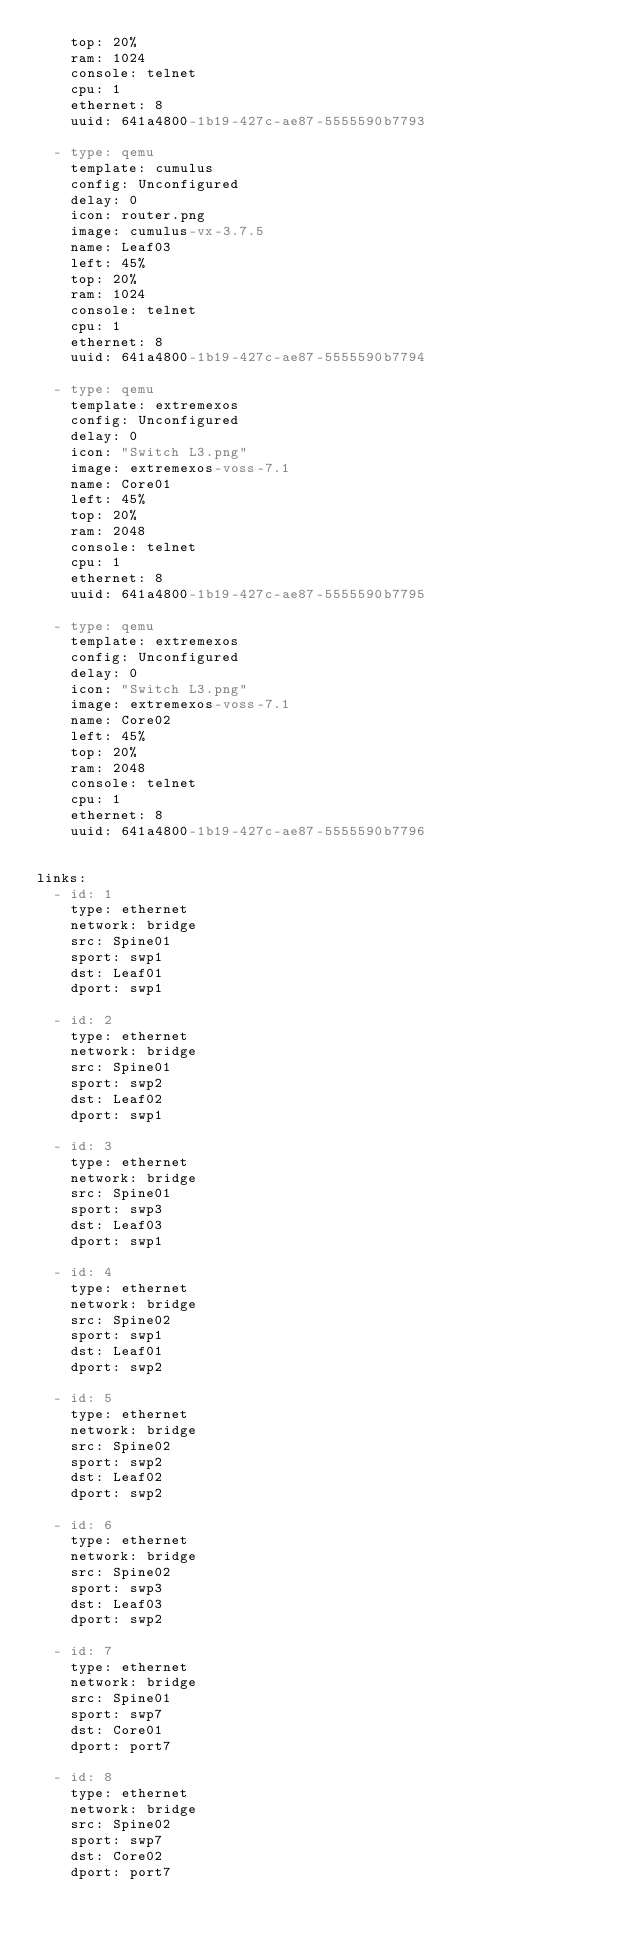Convert code to text. <code><loc_0><loc_0><loc_500><loc_500><_YAML_>    top: 20%
    ram: 1024
    console: telnet
    cpu: 1
    ethernet: 8
    uuid: 641a4800-1b19-427c-ae87-5555590b7793

  - type: qemu
    template: cumulus
    config: Unconfigured
    delay: 0
    icon: router.png
    image: cumulus-vx-3.7.5
    name: Leaf03
    left: 45%
    top: 20%
    ram: 1024
    console: telnet
    cpu: 1
    ethernet: 8
    uuid: 641a4800-1b19-427c-ae87-5555590b7794

  - type: qemu
    template: extremexos
    config: Unconfigured
    delay: 0
    icon: "Switch L3.png"
    image: extremexos-voss-7.1
    name: Core01
    left: 45%
    top: 20%
    ram: 2048
    console: telnet
    cpu: 1
    ethernet: 8
    uuid: 641a4800-1b19-427c-ae87-5555590b7795

  - type: qemu
    template: extremexos
    config: Unconfigured
    delay: 0
    icon: "Switch L3.png"
    image: extremexos-voss-7.1
    name: Core02
    left: 45%
    top: 20%
    ram: 2048
    console: telnet
    cpu: 1
    ethernet: 8
    uuid: 641a4800-1b19-427c-ae87-5555590b7796


links:
  - id: 1
    type: ethernet
    network: bridge
    src: Spine01
    sport: swp1
    dst: Leaf01
    dport: swp1

  - id: 2
    type: ethernet
    network: bridge
    src: Spine01
    sport: swp2
    dst: Leaf02
    dport: swp1

  - id: 3
    type: ethernet
    network: bridge
    src: Spine01
    sport: swp3
    dst: Leaf03
    dport: swp1

  - id: 4
    type: ethernet
    network: bridge
    src: Spine02
    sport: swp1
    dst: Leaf01
    dport: swp2

  - id: 5
    type: ethernet
    network: bridge
    src: Spine02
    sport: swp2
    dst: Leaf02
    dport: swp2

  - id: 6
    type: ethernet
    network: bridge
    src: Spine02
    sport: swp3
    dst: Leaf03
    dport: swp2

  - id: 7
    type: ethernet
    network: bridge
    src: Spine01
    sport: swp7
    dst: Core01
    dport: port7

  - id: 8
    type: ethernet
    network: bridge
    src: Spine02
    sport: swp7
    dst: Core02
    dport: port7




</code> 